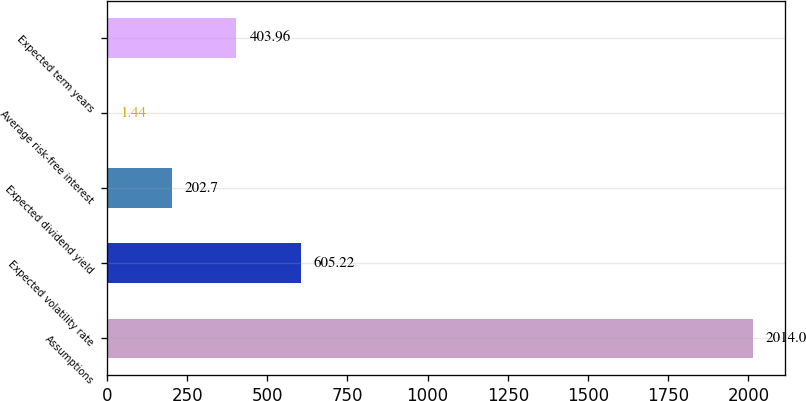Convert chart to OTSL. <chart><loc_0><loc_0><loc_500><loc_500><bar_chart><fcel>Assumptions<fcel>Expected volatility rate<fcel>Expected dividend yield<fcel>Average risk-free interest<fcel>Expected term years<nl><fcel>2014<fcel>605.22<fcel>202.7<fcel>1.44<fcel>403.96<nl></chart> 